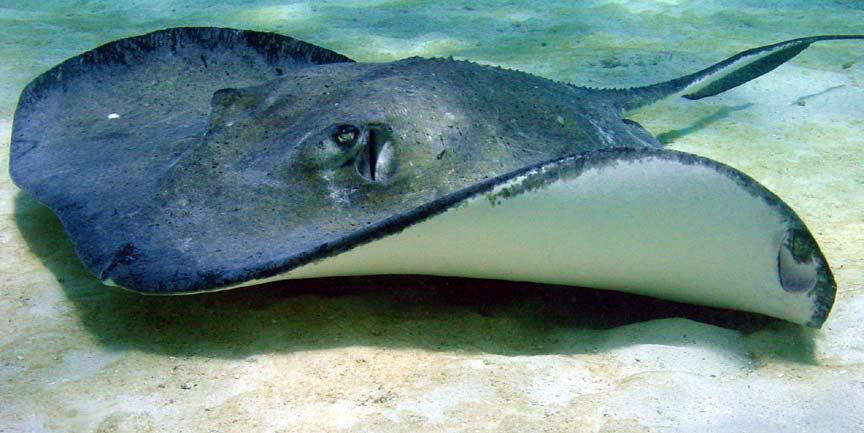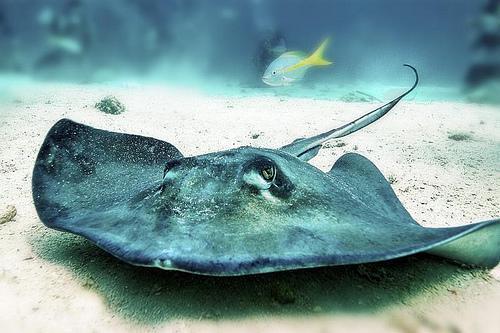The first image is the image on the left, the second image is the image on the right. Considering the images on both sides, is "There is a stingray facing right in the right image." valid? Answer yes or no. No. 